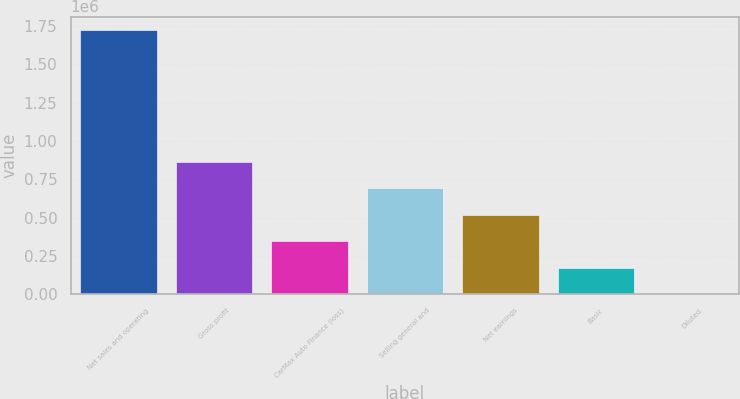Convert chart to OTSL. <chart><loc_0><loc_0><loc_500><loc_500><bar_chart><fcel>Net sales and operating<fcel>Gross profit<fcel>CarMax Auto Finance (loss)<fcel>Selling general and<fcel>Net earnings<fcel>Basic<fcel>Diluted<nl><fcel>1.72598e+06<fcel>862989<fcel>345196<fcel>690391<fcel>517793<fcel>172598<fcel>0.33<nl></chart> 